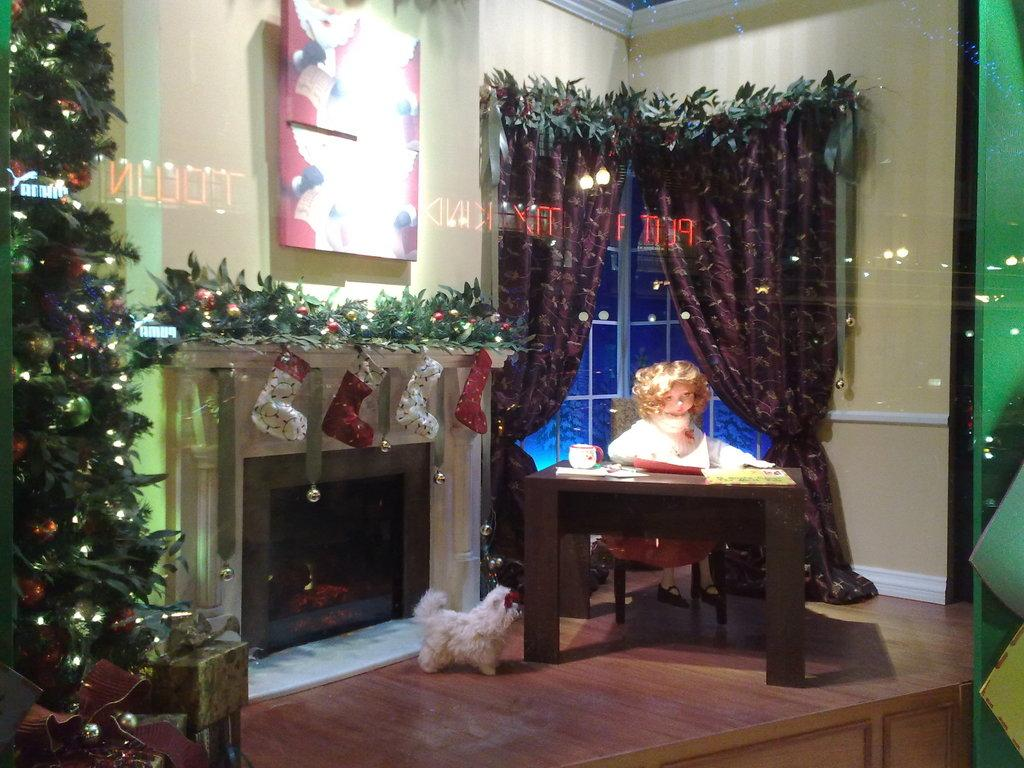What is the main subject in the image? There is a doll in the image. What else can be seen on the table in the image? There is a cup on a table in the image. What is on the floor in the image? There is a dog on the floor in the image. What season might the image be depicting? The presence of a Christmas tree in the image suggests that it might be depicting the Christmas season. How many eggs are on the dog's tongue in the image? There are no eggs or tongues visible in the image; it features a doll, a cup on a table, a dog on the floor, and a Christmas tree. 